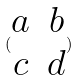<formula> <loc_0><loc_0><loc_500><loc_500>( \begin{matrix} a & b \\ c & d \end{matrix} )</formula> 